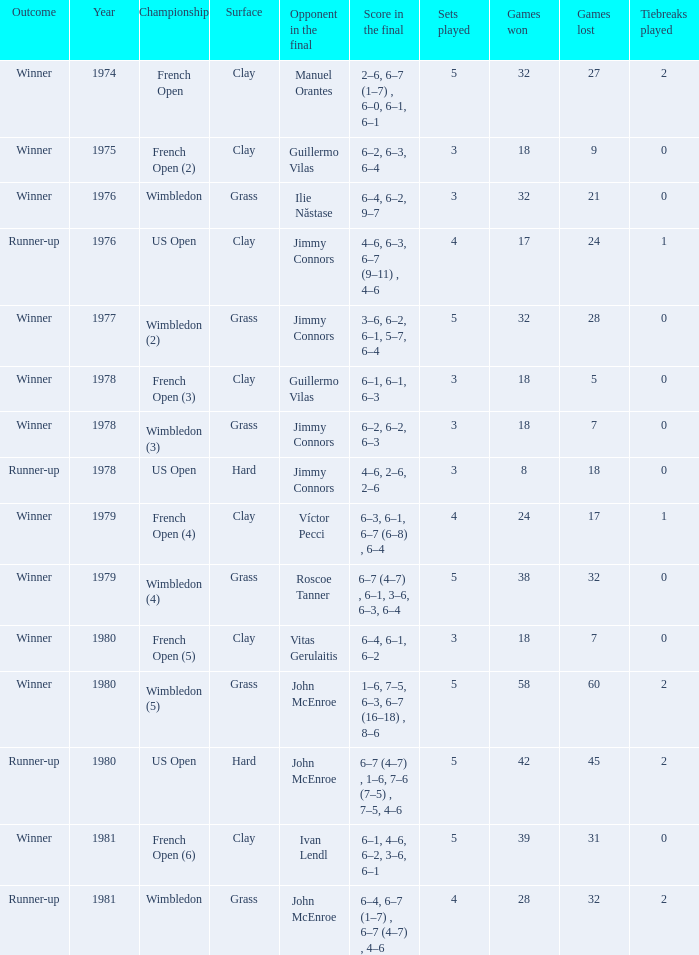What is every year where opponent in the final is John Mcenroe at Wimbledon? 1981.0. 